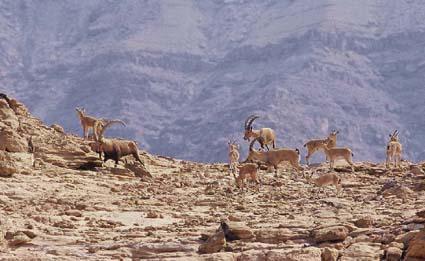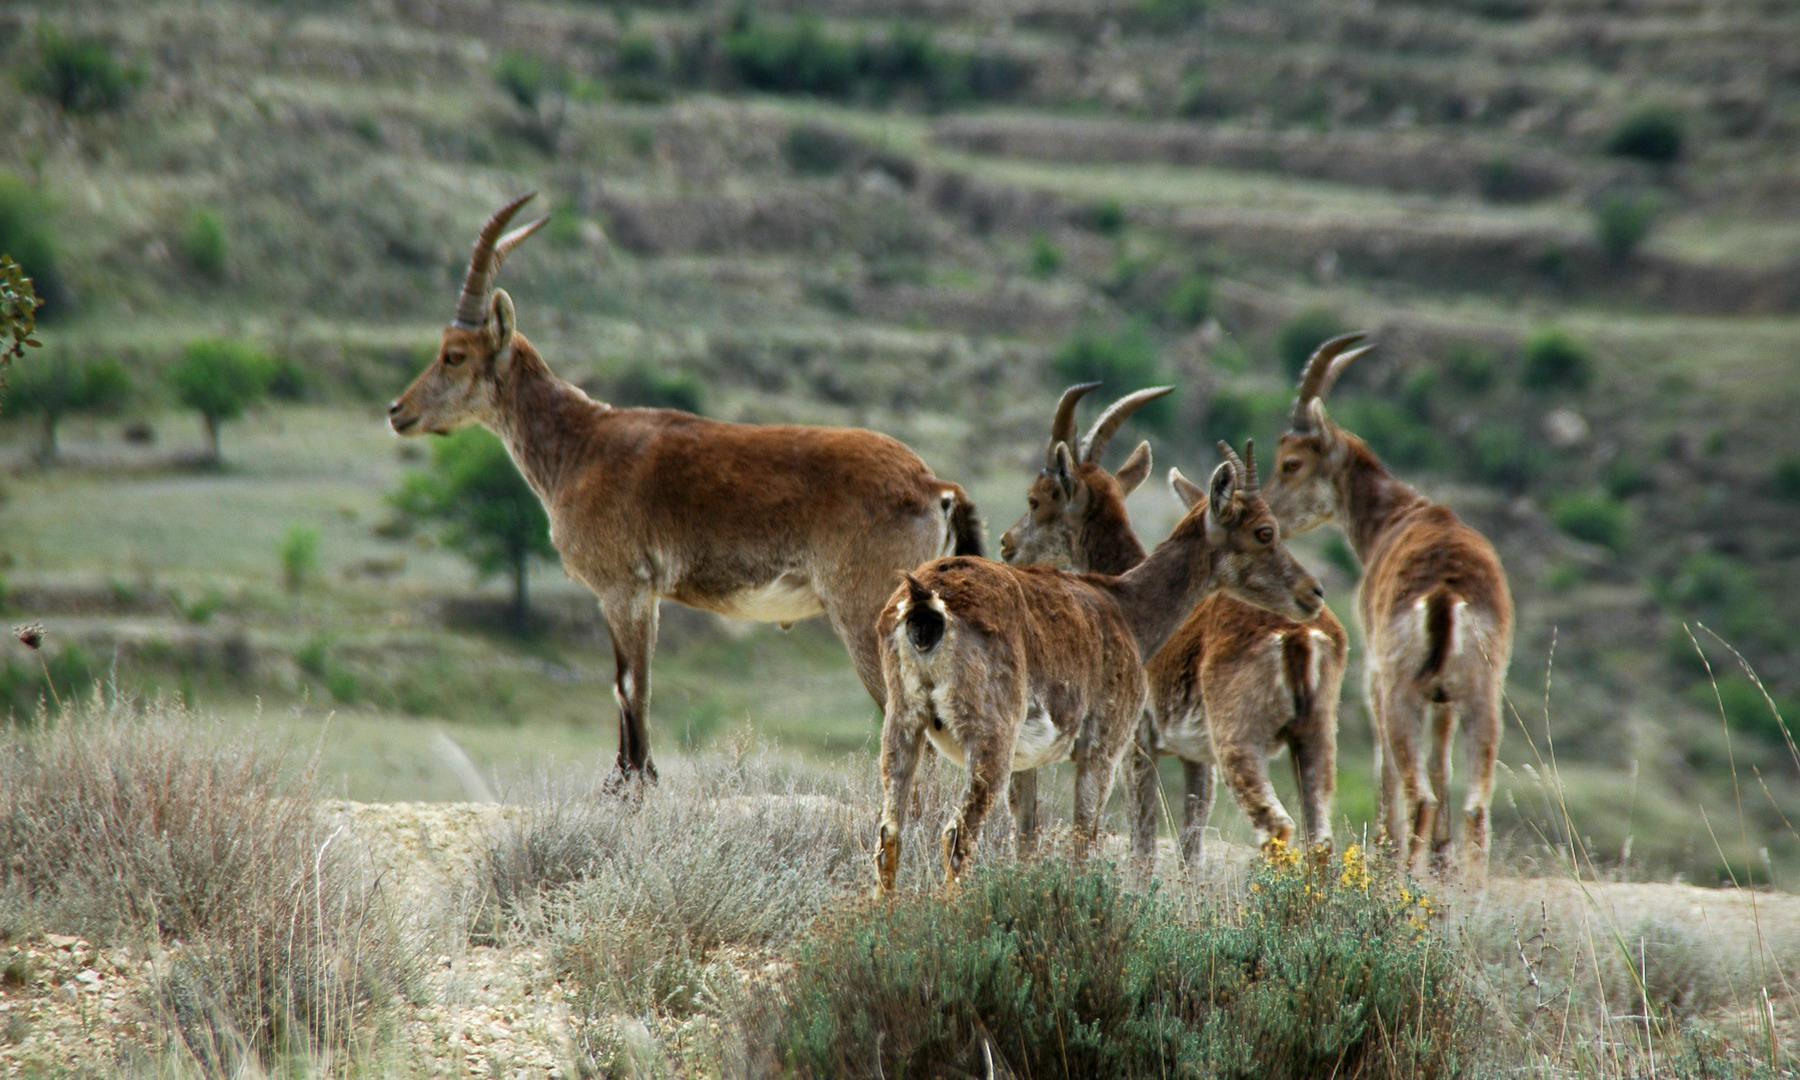The first image is the image on the left, the second image is the image on the right. For the images displayed, is the sentence "There are more than four animals in the image on the left." factually correct? Answer yes or no. Yes. The first image is the image on the left, the second image is the image on the right. Given the left and right images, does the statement "A majority of horned animals in one image are rear-facing, and the other image shows a rocky ledge that drops off." hold true? Answer yes or no. Yes. 